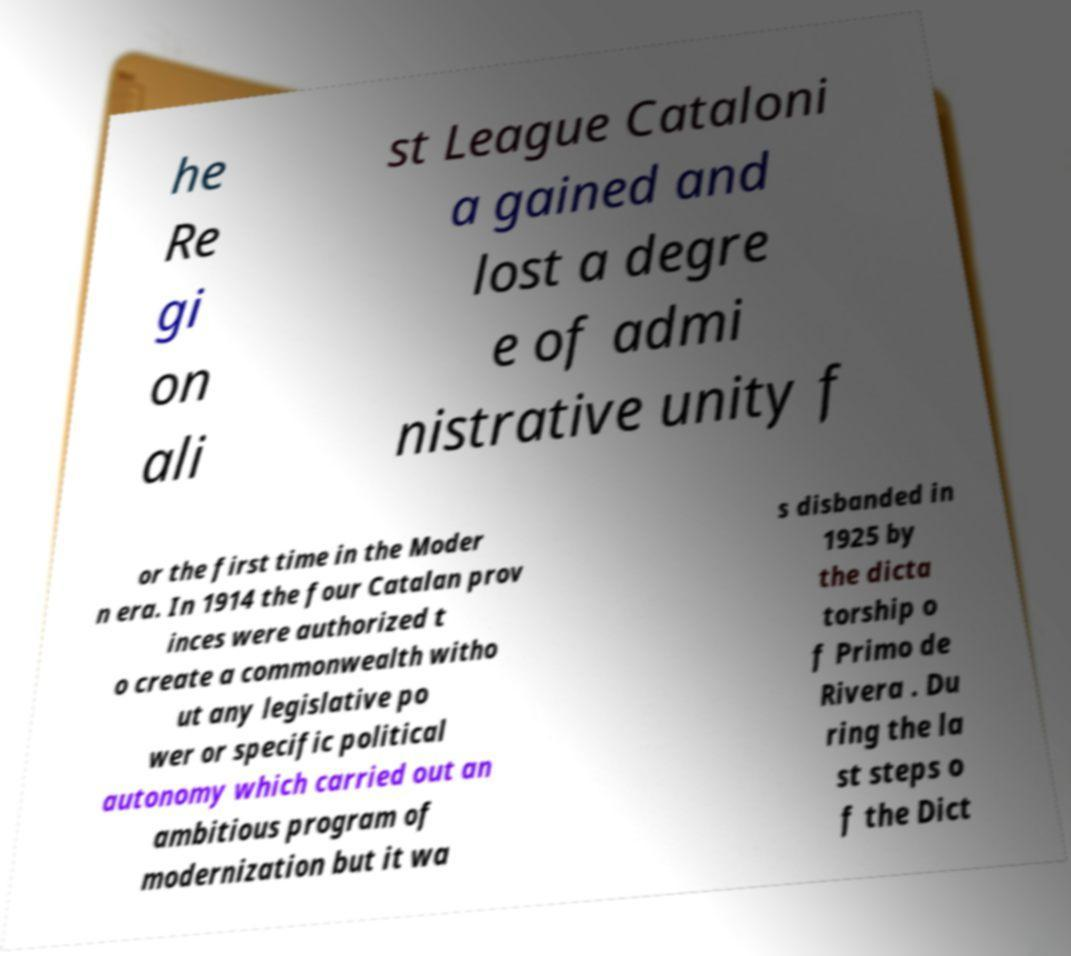Can you read and provide the text displayed in the image?This photo seems to have some interesting text. Can you extract and type it out for me? he Re gi on ali st League Cataloni a gained and lost a degre e of admi nistrative unity f or the first time in the Moder n era. In 1914 the four Catalan prov inces were authorized t o create a commonwealth witho ut any legislative po wer or specific political autonomy which carried out an ambitious program of modernization but it wa s disbanded in 1925 by the dicta torship o f Primo de Rivera . Du ring the la st steps o f the Dict 